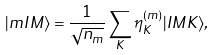Convert formula to latex. <formula><loc_0><loc_0><loc_500><loc_500>| m I M \rangle = \frac { 1 } { \sqrt { n _ { m } } } \sum _ { K } \eta _ { K } ^ { ( m ) } | I M K \rangle ,</formula> 